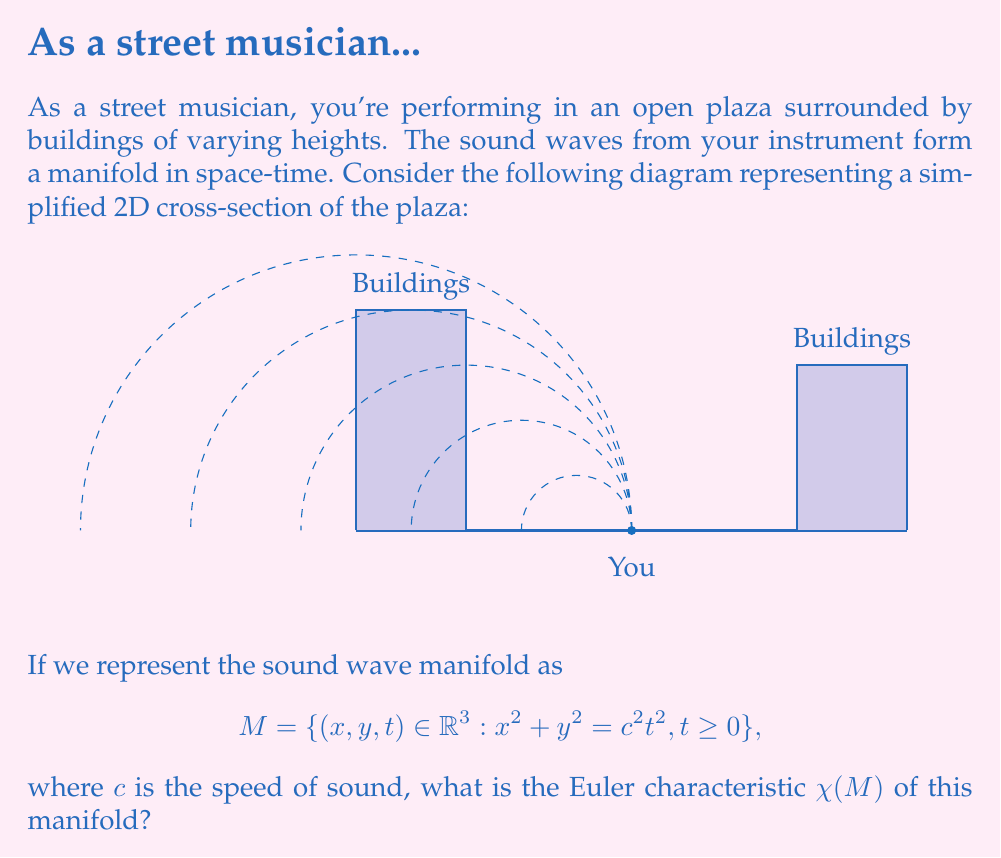Provide a solution to this math problem. To determine the Euler characteristic of the sound wave manifold, let's analyze its properties step by step:

1) The manifold M represents an expanding spherical wave in space-time. In the 2D cross-section shown, it appears as expanding circular waves.

2) The equation $x^2 + y^2 = c^2t^2, t \geq 0$ describes a cone in 3D space-time, with the vertex at the origin (0,0,0).

3) Topologically, this manifold is equivalent to a half-cone (since t ≥ 0).

4) To calculate the Euler characteristic, we need to consider the topological properties of this half-cone:

   a) It has one face (the curved surface)
   b) It has one edge (the circular base)
   c) It has one vertex (the point at the origin)

5) The Euler characteristic is calculated using the formula:

   $$\chi = V - E + F$$

   where V is the number of vertices, E is the number of edges, and F is the number of faces.

6) Substituting our values:

   $$\chi = 1 - 1 + 1 = 1$$

Therefore, the Euler characteristic of the sound wave manifold M is 1.

Note: The buildings and reflections don't affect the topology of the initial wavefront, although they would create a more complex wave pattern in reality.
Answer: $\chi(M) = 1$ 